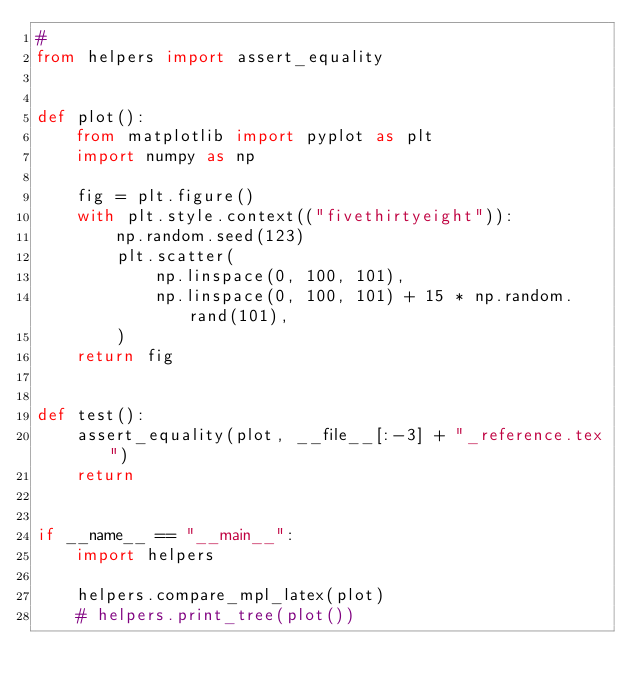Convert code to text. <code><loc_0><loc_0><loc_500><loc_500><_Python_>#
from helpers import assert_equality


def plot():
    from matplotlib import pyplot as plt
    import numpy as np

    fig = plt.figure()
    with plt.style.context(("fivethirtyeight")):
        np.random.seed(123)
        plt.scatter(
            np.linspace(0, 100, 101),
            np.linspace(0, 100, 101) + 15 * np.random.rand(101),
        )
    return fig


def test():
    assert_equality(plot, __file__[:-3] + "_reference.tex")
    return


if __name__ == "__main__":
    import helpers

    helpers.compare_mpl_latex(plot)
    # helpers.print_tree(plot())
</code> 